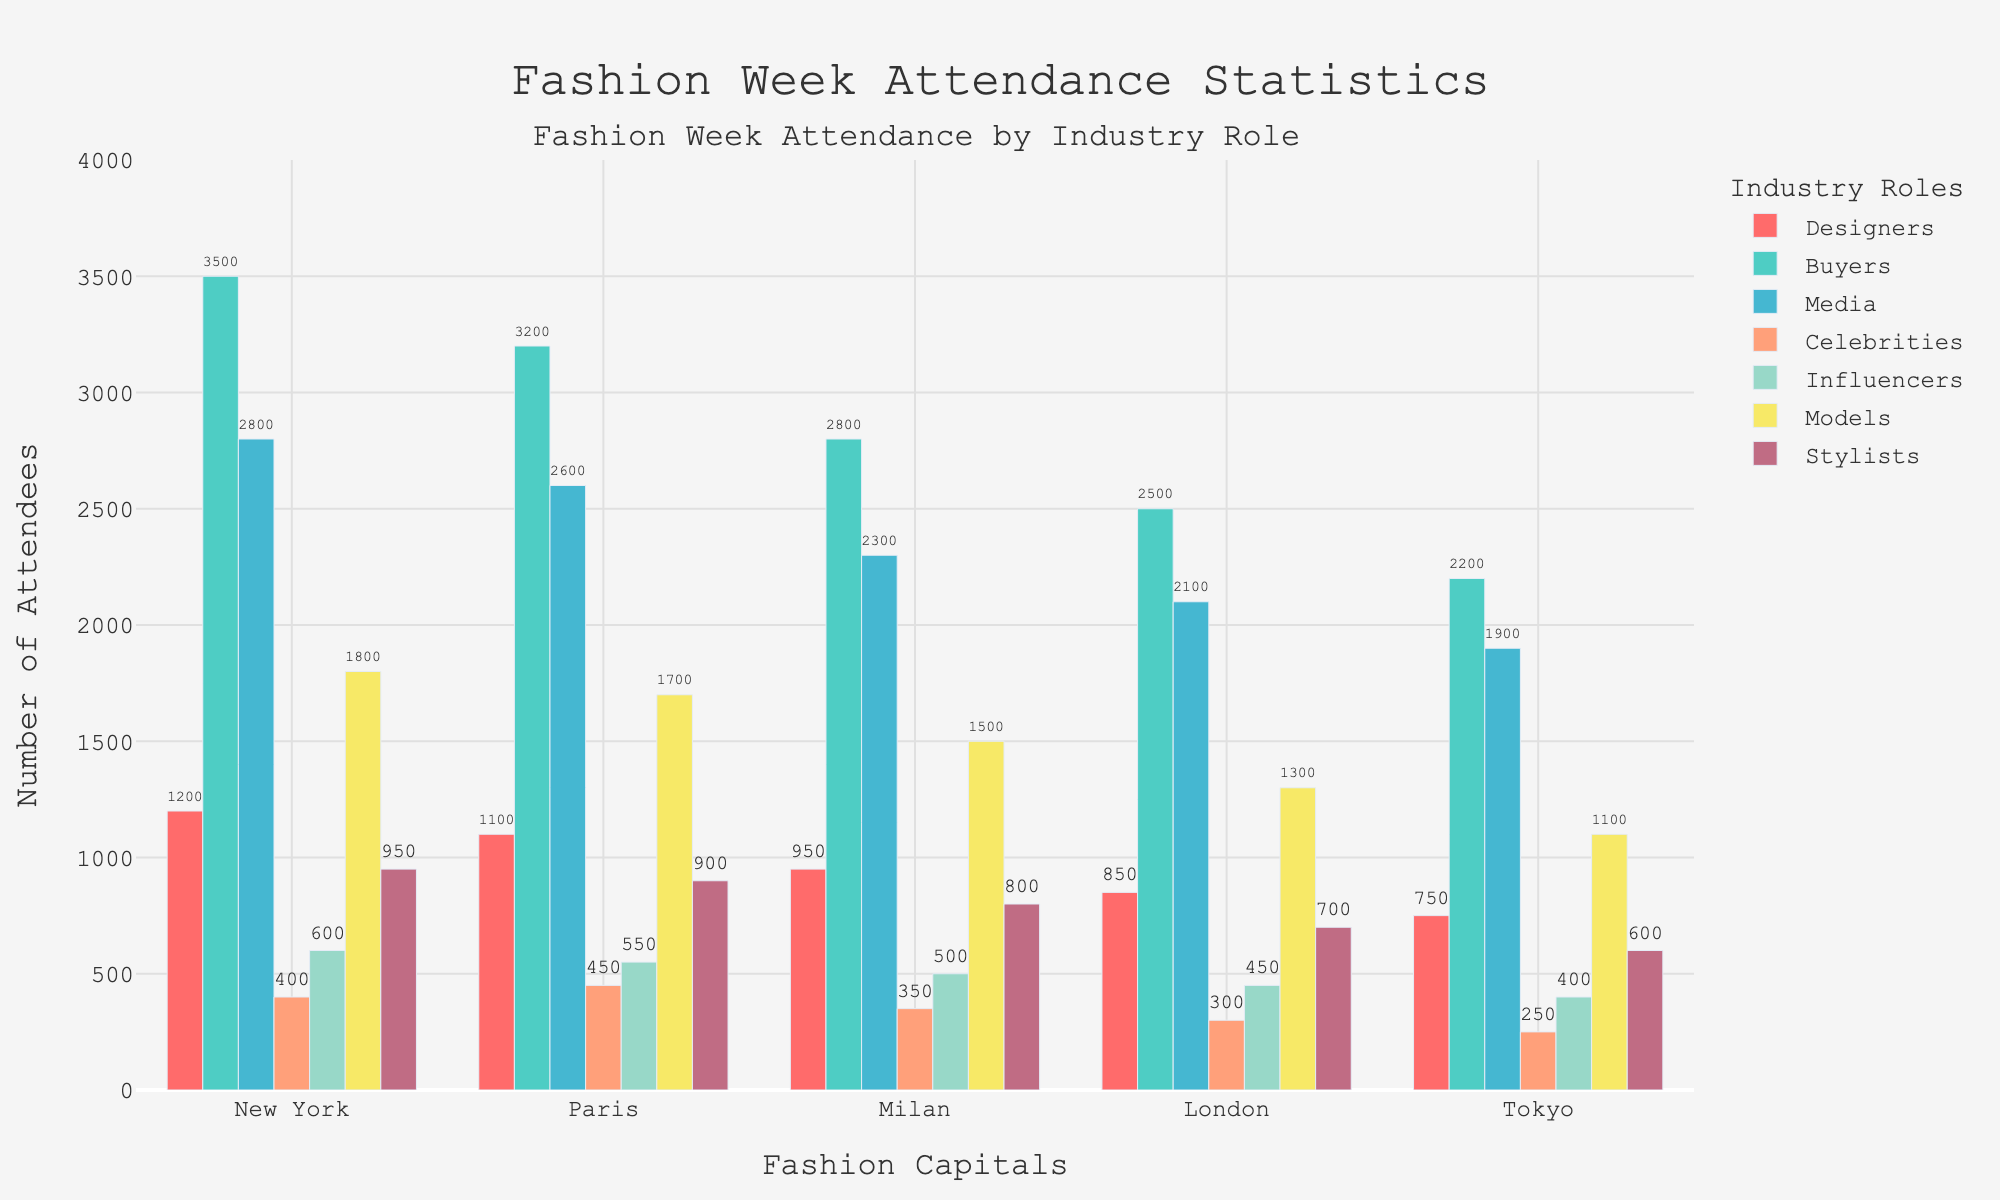What is the total number of attendees for each role across all fashion capitals? To get the total number of attendees for each role, add the number of attendees from each city for that role. For example, for Designers, it would be 1200 (New York) + 1100 (Paris) + 950 (Milan) + 850 (London) + 750 (Tokyo) = 4850. Repeat this process for all other roles.
Answer: Designers: 4850, Buyers: 14200, Media: 11700, Celebrities: 1750, Influencers: 2500, Models: 7400, Stylists: 3950 Which city had the highest number of buyers? To find the city with the highest number of buyers, compare the values for Buyers in each city. The Buyers values are: New York (3500), Paris (3200), Milan (2800), London (2500), Tokyo (2200). New York had the highest number with 3500 buyers.
Answer: New York Which city had the least number of models, and what was the number? To determine the city with the least number of models, compare the Models values: New York (1800), Paris (1700), Milan (1500), London (1300), Tokyo (1100). Tokyo had the least number of models with 1100.
Answer: Tokyo, 1100 What is the difference in the number of media attendees between New York and Tokyo? To find the difference in the number of media attendees between New York and Tokyo, subtract the number of media attendees in Tokyo (1900) from the number in New York (2800). So, 2800 - 1900 = 900.
Answer: 900 How many more attendees in total does New York have compared to Tokyo? Calculate the total attendees for New York and Tokyo by summing up their respective values, then find the difference. New York total: 1200 + 3500 + 2800 + 400 + 600 + 1800 + 950 = 11250. Tokyo total: 750 + 2200 + 1900 + 250 + 400 + 1100 + 600 = 7200. The difference is 11250 - 7200 = 4050.
Answer: 4050 Which role had the smallest number of attendees in Milan? To determine the role with the smallest number of attendees in Milan, compare the values for each role: Designers (950), Buyers (2800), Media (2300), Celebrities (350), Influencers (500), Models (1500), Stylists (800). The role with the smallest number is Celebrities with 350.
Answer: Celebrities What is the average number of stylists across all five cities? To find the average number of stylists, add the number of stylists in each city and divide by 5. So, (950 + 900 + 800 + 700 + 600) / 5 = 3950 / 5 = 790.
Answer: 790 Which city had a higher number of influencers, Paris or London, and by how much? Compare the number of influencers between Paris (550) and London (450), and calculate the difference. Paris had 100 more influencers than London.
Answer: Paris, 100 Which industry role has the most attendees in Paris? Look at the attendees for each role in Paris: Designers (1100), Buyers (3200), Media (2600), Celebrities (450), Influencers (550), Models (1700), Stylists (900). Buyers has the most attendees with 3200.
Answer: Buyers 